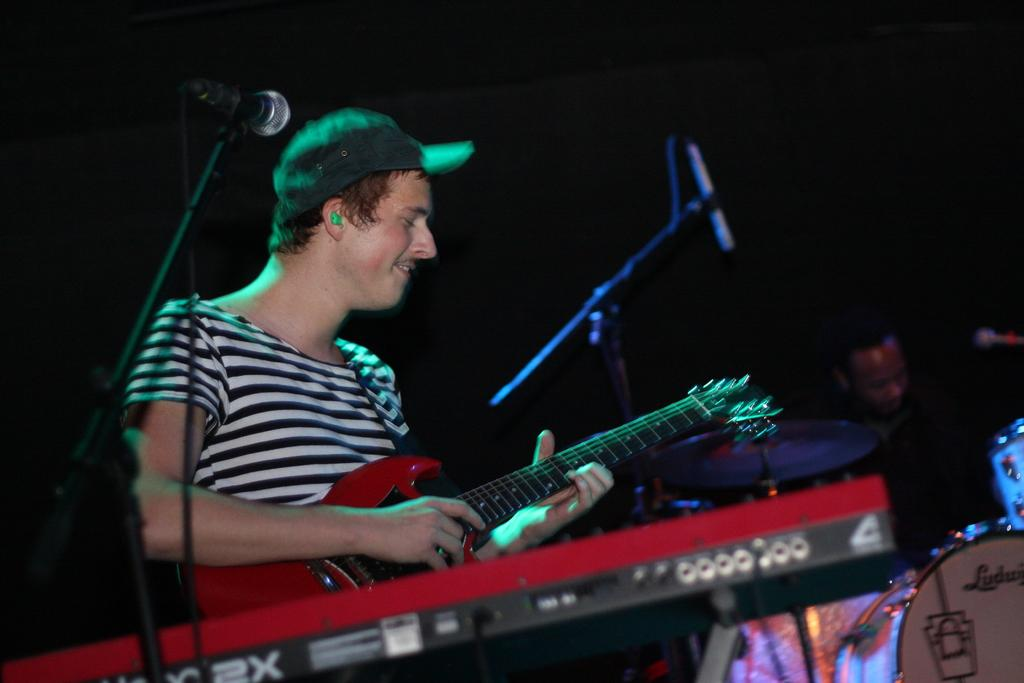What is the man in the image doing? The man is standing and playing a guitar in the image. What is the other man in the image doing? The other man is sitting and playing the drums in the image. Can you describe the background of the image? The background of the image is dark. How many times does the man sneeze while playing the guitar in the image? There is no indication in the image that the man is sneezing while playing the guitar. Is there a bathtub visible in the image? No, there is no bathtub present in the image. 